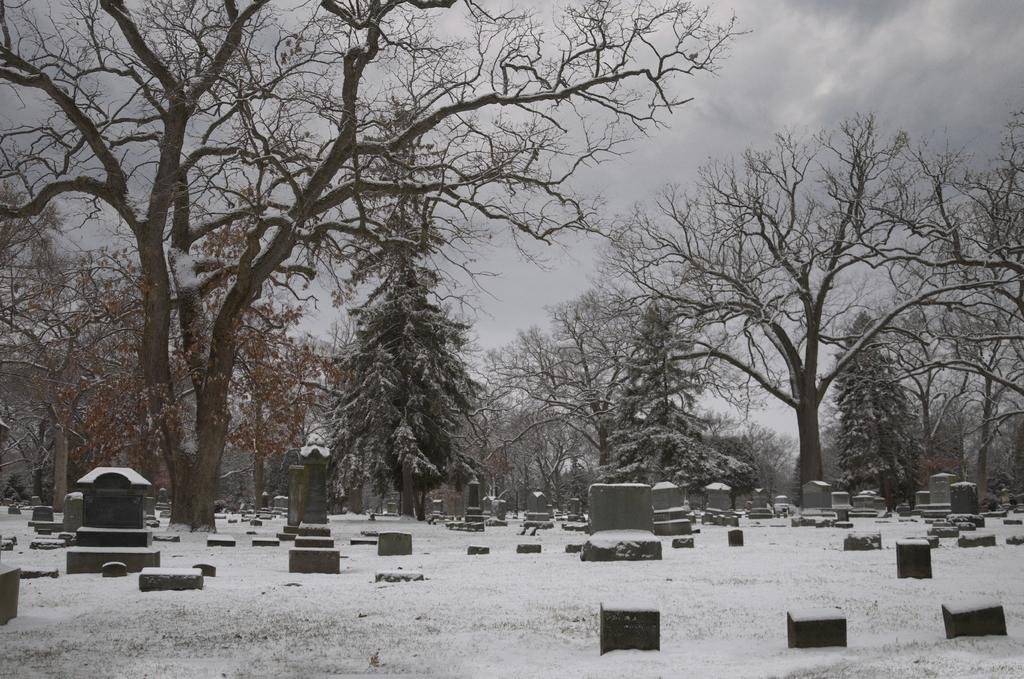What type of natural environment is depicted in the image? There are many trees in the image, suggesting a forest or wooded area. What weather condition is present in the image? There is snow visible in the image, indicating a cold or wintery environment. What type of location can be seen in the image? There is a graveyard in the image, which is a place for burial and remembrance of the deceased. What is the condition of the sky in the image? The sky is cloudy in the image, which may contribute to the cold and snowy conditions. What type of calendar is hanging on the tree in the image? There is no calendar present in the image; it features trees, snow, a graveyard, and a cloudy sky. Can you describe the pot used for cooking in the image? There is no pot for cooking present in the image. 